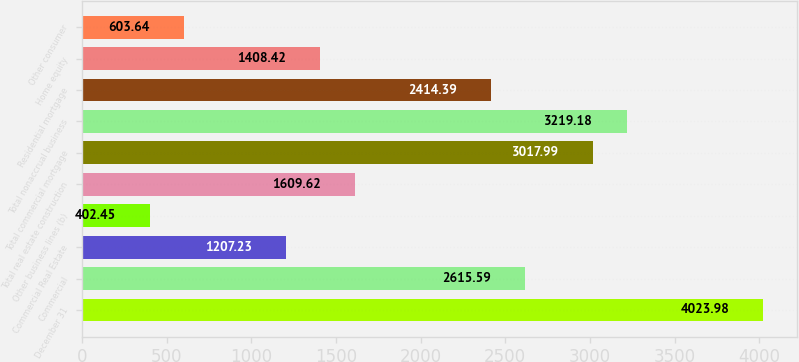Convert chart. <chart><loc_0><loc_0><loc_500><loc_500><bar_chart><fcel>December 31<fcel>Commercial<fcel>Commercial Real Estate<fcel>Other business lines (b)<fcel>Total real estate construction<fcel>Total commercial mortgage<fcel>Total nonaccrual business<fcel>Residential mortgage<fcel>Home equity<fcel>Other consumer<nl><fcel>4023.98<fcel>2615.59<fcel>1207.23<fcel>402.45<fcel>1609.62<fcel>3017.99<fcel>3219.18<fcel>2414.39<fcel>1408.42<fcel>603.64<nl></chart> 